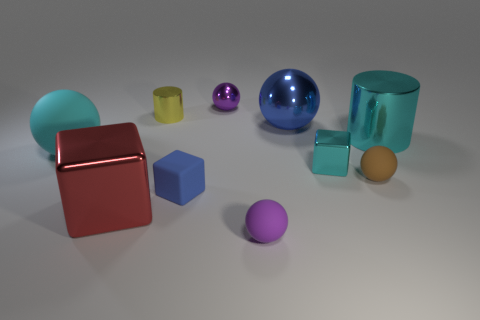Subtract 2 spheres. How many spheres are left? 3 Subtract all blue spheres. How many spheres are left? 4 Subtract all cyan balls. How many balls are left? 4 Subtract all gray spheres. Subtract all blue cubes. How many spheres are left? 5 Subtract all cylinders. How many objects are left? 8 Add 7 small green metal cylinders. How many small green metal cylinders exist? 7 Subtract 1 cyan spheres. How many objects are left? 9 Subtract all cyan metal objects. Subtract all cylinders. How many objects are left? 6 Add 2 large rubber spheres. How many large rubber spheres are left? 3 